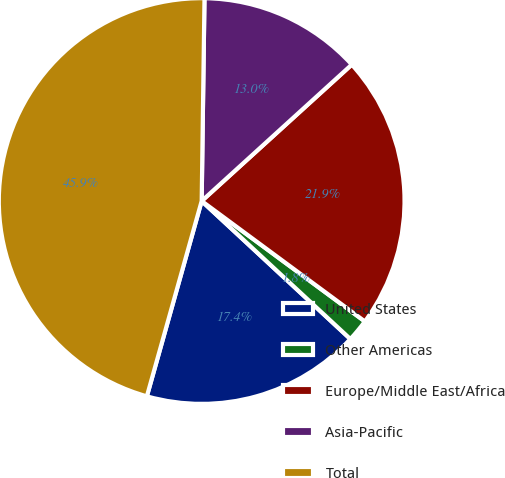Convert chart to OTSL. <chart><loc_0><loc_0><loc_500><loc_500><pie_chart><fcel>United States<fcel>Other Americas<fcel>Europe/Middle East/Africa<fcel>Asia-Pacific<fcel>Total<nl><fcel>17.45%<fcel>1.79%<fcel>21.86%<fcel>13.04%<fcel>45.87%<nl></chart> 